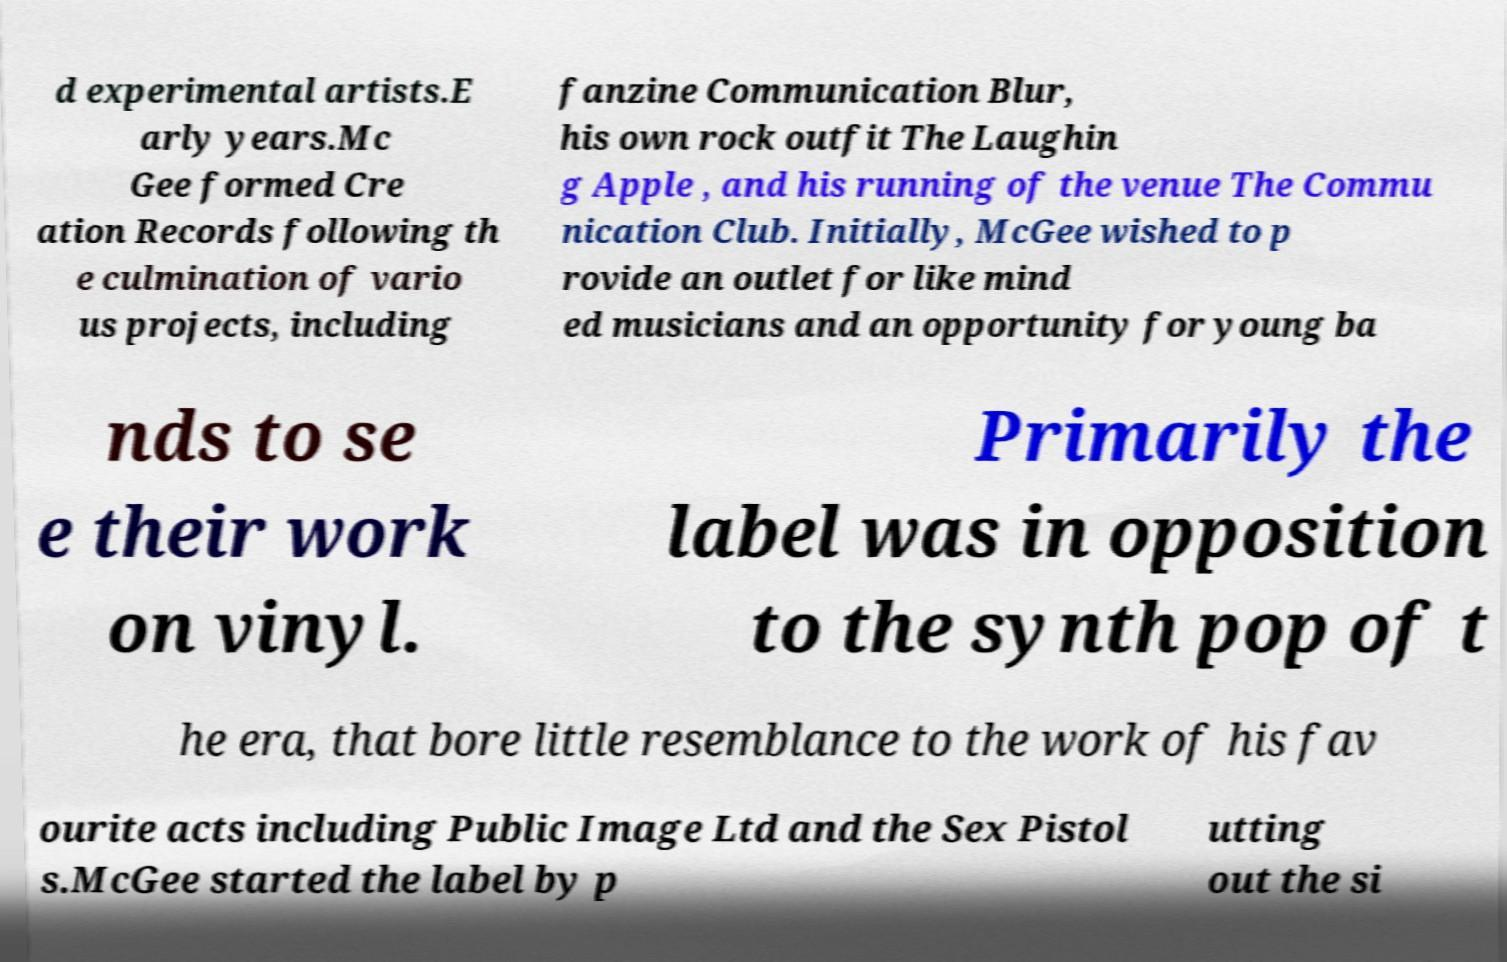Could you assist in decoding the text presented in this image and type it out clearly? d experimental artists.E arly years.Mc Gee formed Cre ation Records following th e culmination of vario us projects, including fanzine Communication Blur, his own rock outfit The Laughin g Apple , and his running of the venue The Commu nication Club. Initially, McGee wished to p rovide an outlet for like mind ed musicians and an opportunity for young ba nds to se e their work on vinyl. Primarily the label was in opposition to the synth pop of t he era, that bore little resemblance to the work of his fav ourite acts including Public Image Ltd and the Sex Pistol s.McGee started the label by p utting out the si 